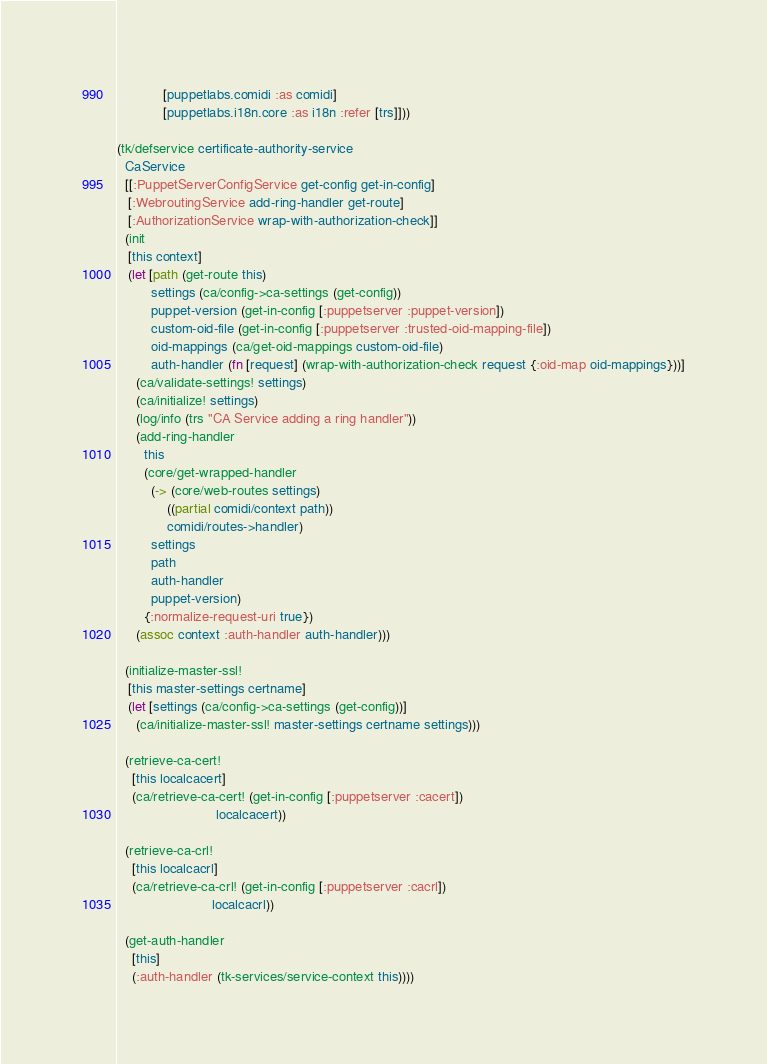Convert code to text. <code><loc_0><loc_0><loc_500><loc_500><_Clojure_>            [puppetlabs.comidi :as comidi]
            [puppetlabs.i18n.core :as i18n :refer [trs]]))

(tk/defservice certificate-authority-service
  CaService
  [[:PuppetServerConfigService get-config get-in-config]
   [:WebroutingService add-ring-handler get-route]
   [:AuthorizationService wrap-with-authorization-check]]
  (init
   [this context]
   (let [path (get-route this)
         settings (ca/config->ca-settings (get-config))
         puppet-version (get-in-config [:puppetserver :puppet-version])
         custom-oid-file (get-in-config [:puppetserver :trusted-oid-mapping-file])
         oid-mappings (ca/get-oid-mappings custom-oid-file)
         auth-handler (fn [request] (wrap-with-authorization-check request {:oid-map oid-mappings}))]
     (ca/validate-settings! settings)
     (ca/initialize! settings)
     (log/info (trs "CA Service adding a ring handler"))
     (add-ring-handler
       this
       (core/get-wrapped-handler
         (-> (core/web-routes settings)
             ((partial comidi/context path))
             comidi/routes->handler)
         settings
         path
         auth-handler
         puppet-version)
       {:normalize-request-uri true})
     (assoc context :auth-handler auth-handler)))

  (initialize-master-ssl!
   [this master-settings certname]
   (let [settings (ca/config->ca-settings (get-config))]
     (ca/initialize-master-ssl! master-settings certname settings)))

  (retrieve-ca-cert!
    [this localcacert]
    (ca/retrieve-ca-cert! (get-in-config [:puppetserver :cacert])
                          localcacert))

  (retrieve-ca-crl!
    [this localcacrl]
    (ca/retrieve-ca-crl! (get-in-config [:puppetserver :cacrl])
                         localcacrl))

  (get-auth-handler
    [this]
    (:auth-handler (tk-services/service-context this))))
</code> 